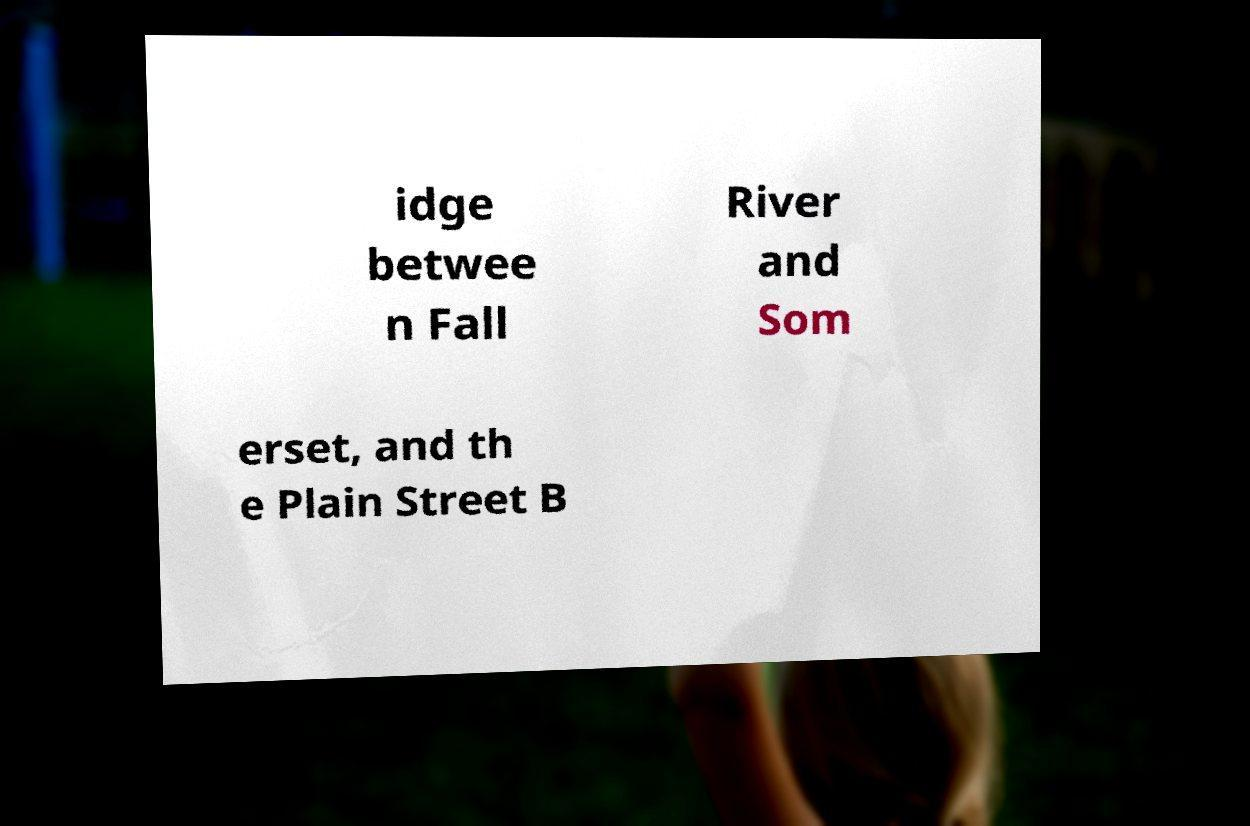For documentation purposes, I need the text within this image transcribed. Could you provide that? idge betwee n Fall River and Som erset, and th e Plain Street B 